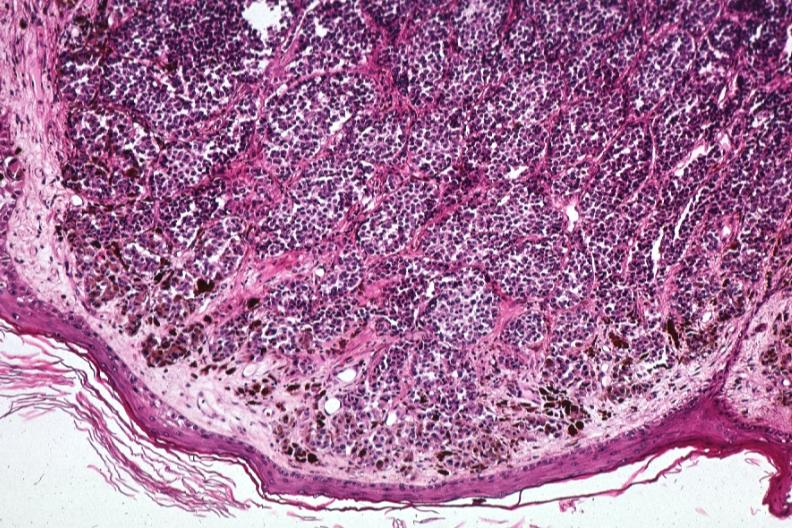what is present?
Answer the question using a single word or phrase. Malignant melanoma 